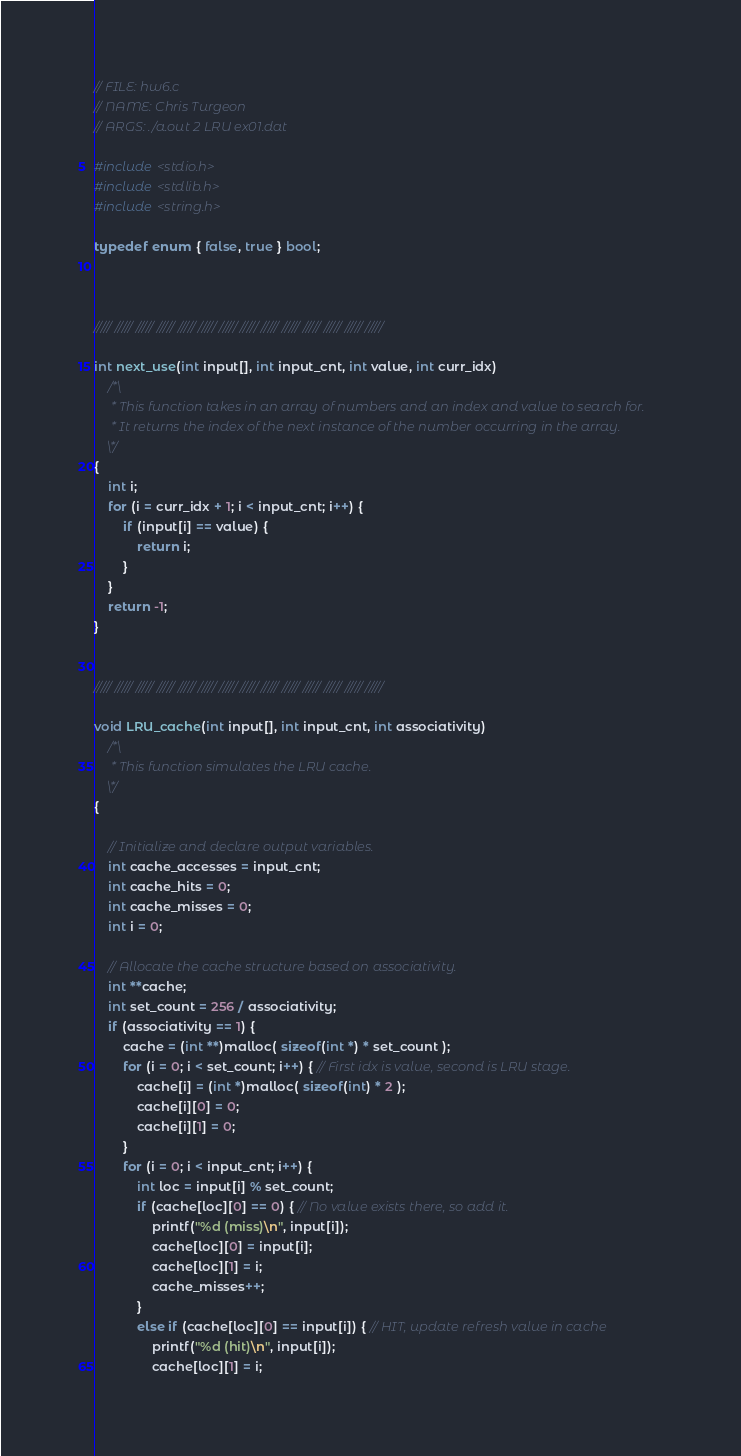Convert code to text. <code><loc_0><loc_0><loc_500><loc_500><_C_>// FILE: hw6.c
// NAME: Chris Turgeon
// ARGS: ./a.out 2 LRU ex01.dat

#include <stdio.h>
#include <stdlib.h>
#include <string.h>

typedef enum { false, true } bool;



///// ///// ///// ///// ///// ///// ///// ///// ///// ///// ///// ///// ///// /////

int next_use(int input[], int input_cnt, int value, int curr_idx) 
	/*\ 
	 * This function takes in an array of numbers and an index and value to search for.
	 * It returns the index of the next instance of the number occurring in the array.
	\*/
{
	int i;
	for (i = curr_idx + 1; i < input_cnt; i++) {
		if (input[i] == value) {
			return i;
		}
	}
	return -1;
}


///// ///// ///// ///// ///// ///// ///// ///// ///// ///// ///// ///// ///// /////

void LRU_cache(int input[], int input_cnt, int associativity) 
	/*\
	 * This function simulates the LRU cache.
	\*/
{

	// Initialize and declare output variables.
	int cache_accesses = input_cnt;
	int cache_hits = 0;
	int cache_misses = 0;
	int i = 0;

	// Allocate the cache structure based on associativity.
	int **cache;
	int set_count = 256 / associativity;
	if (associativity == 1) {
		cache = (int **)malloc( sizeof(int *) * set_count );
		for (i = 0; i < set_count; i++) { // First idx is value, second is LRU stage.
			cache[i] = (int *)malloc( sizeof(int) * 2 );
			cache[i][0] = 0;
			cache[i][1] = 0;
		}
		for (i = 0; i < input_cnt; i++) { 
			int loc = input[i] % set_count; 
			if (cache[loc][0] == 0) { // No value exists there, so add it.
				printf("%d (miss)\n", input[i]);
				cache[loc][0] = input[i]; 
				cache[loc][1] = i;
				cache_misses++;
			}   
			else if (cache[loc][0] == input[i]) { // HIT, update refresh value in cache
				printf("%d (hit)\n", input[i]);
				cache[loc][1] = i;</code> 